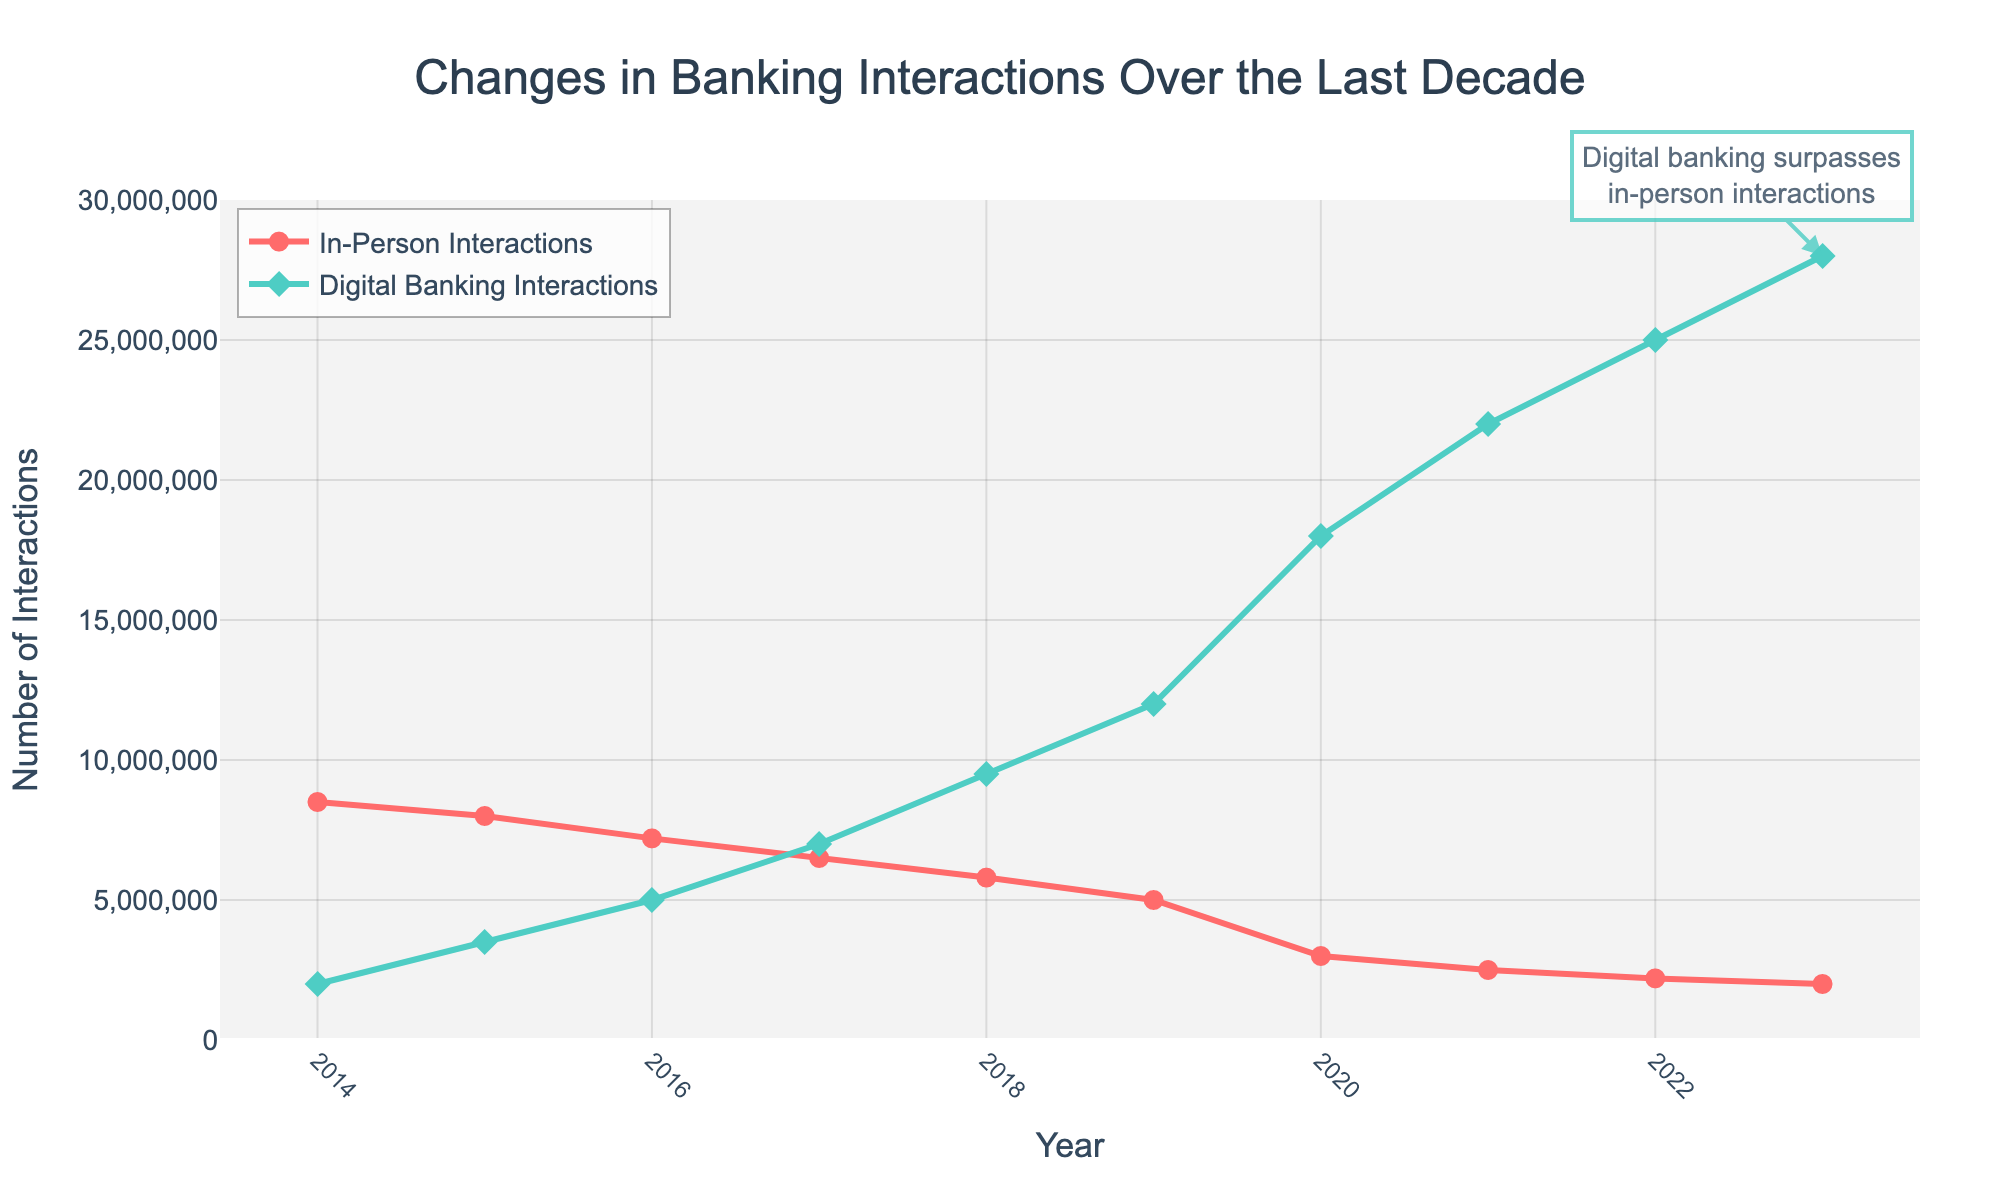Which year did digital banking interactions surpass in-person interactions? Observe the intersection point of the two lines. The intersection occurs between the in-person interactions (red line) and the digital banking interactions (green line). This happens around the year 2017.
Answer: 2017 What is the difference in the number of digital banking interactions between 2020 and 2023? Look at the digital banking interactions values for 2020 (18,000,000) and for 2023 (28,000,000). Subtract the 2020 value from the 2023 value, i.e., 28,000,000 - 18,000,000 = 10,000,000.
Answer: 10,000,000 How has the number of in-person interactions changed from 2014 to 2023? Observe the data points of in-person interactions in 2014 and 2023. The number of interactions in 2014 is 8,500,000 and in 2023 it is 2,000,000. The change is a decrease. Calculate the difference, 8,500,000 - 2,000,000 = 6,500,000.
Answer: Decreased by 6,500,000 Which year had the highest number of in-person interactions? Identify the highest point of the red line (In-Person Interactions). This occurs in the year 2014, with a value of 8,500,000.
Answer: 2014 In which year did digital banking interactions first exceed 10,000,000? Find the data points of digital banking interactions and check when the values exceed 10,000,000 for the first time. It occurs in the year 2019 with a value of 12,000,000.
Answer: 2019 What is the average number of digital banking interactions from 2014 to 2023? Sum all the values of digital banking interactions from 2014 to 2023 and divide by the number of years. (2,000,000 + 3,500,000 + 5,000,000 + 7,000,000 + 9,500,000 + 12,000,000 + 18,000,000 + 22,000,000 + 25,000,000 + 28,000,000) / 10 = 13,000,000.
Answer: 13,000,000 